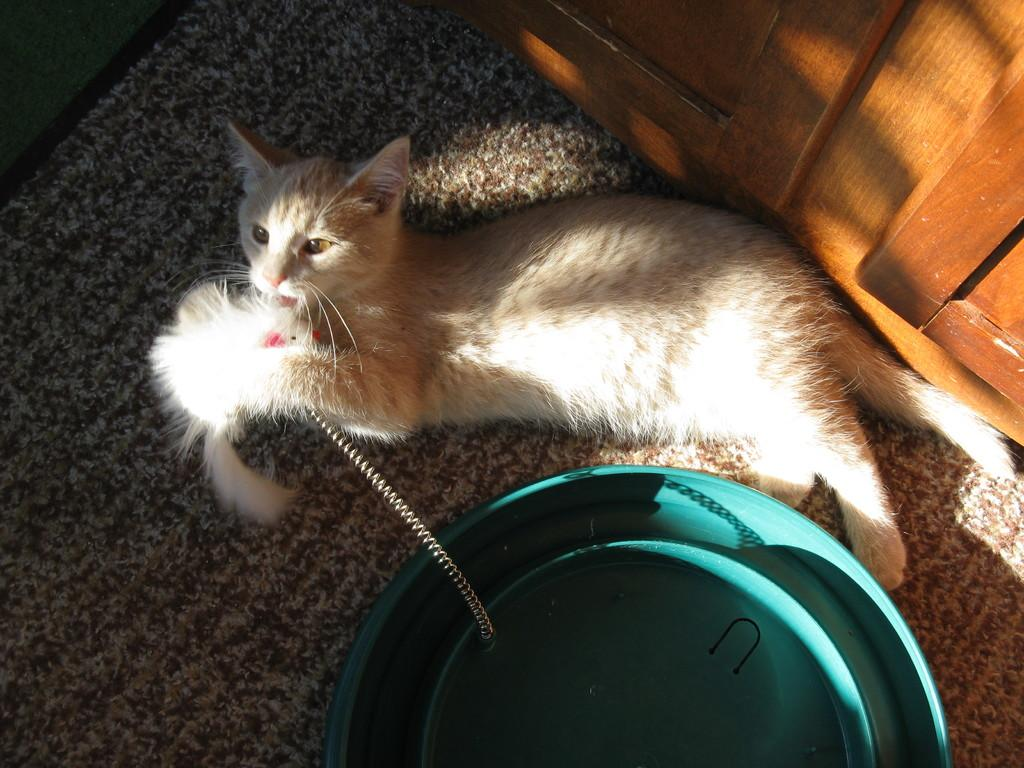What animal is present in the image? There is a cat in the image. Where is the cat located? The cat is on a mat. What other objects can be seen in the image? There is a belt and a container visible in the image. What is in the background of the image? There is a cupboard in the background of the image. How many arches can be seen in the image? There are no arches present in the image. What type of ball is being used by the cat in the image? There is no ball present in the image; it features a cat on a mat with other objects. 